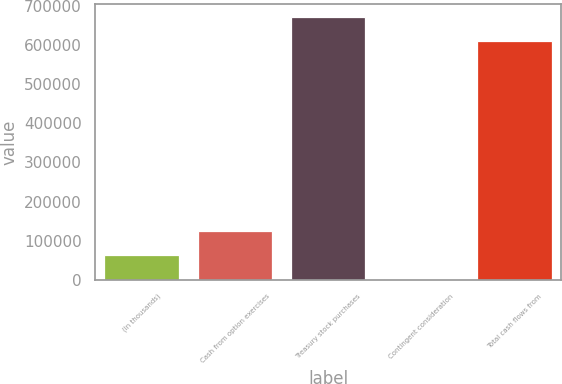Convert chart. <chart><loc_0><loc_0><loc_500><loc_500><bar_chart><fcel>(In thousands)<fcel>Cash from option exercises<fcel>Treasury stock purchases<fcel>Contingent consideration<fcel>Total cash flows from<nl><fcel>63834.6<fcel>125978<fcel>671931<fcel>1691<fcel>609787<nl></chart> 